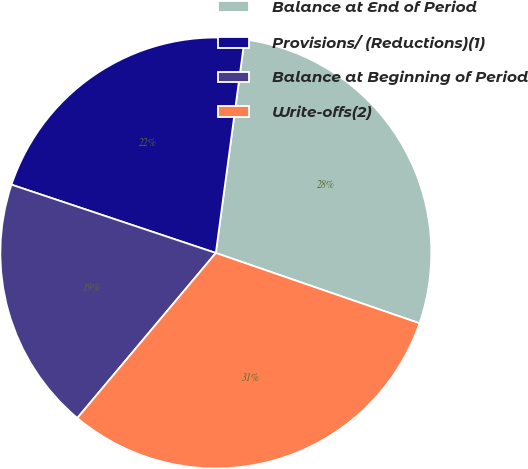Convert chart to OTSL. <chart><loc_0><loc_0><loc_500><loc_500><pie_chart><fcel>Balance at End of Period<fcel>Provisions/ (Reductions)(1)<fcel>Balance at Beginning of Period<fcel>Write-offs(2)<nl><fcel>28.16%<fcel>21.99%<fcel>19.02%<fcel>30.82%<nl></chart> 